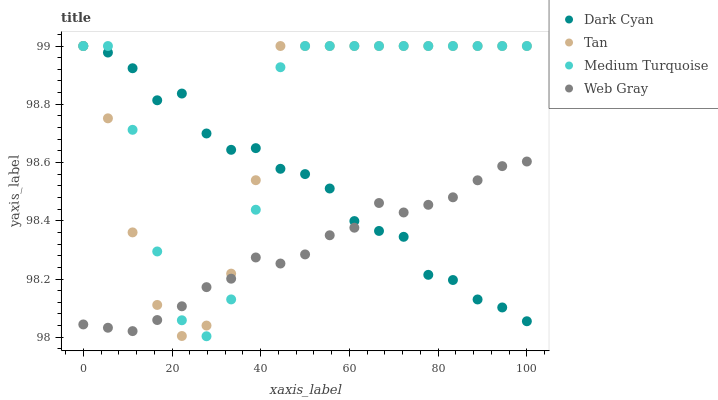Does Web Gray have the minimum area under the curve?
Answer yes or no. Yes. Does Medium Turquoise have the maximum area under the curve?
Answer yes or no. Yes. Does Tan have the minimum area under the curve?
Answer yes or no. No. Does Tan have the maximum area under the curve?
Answer yes or no. No. Is Web Gray the smoothest?
Answer yes or no. Yes. Is Medium Turquoise the roughest?
Answer yes or no. Yes. Is Tan the smoothest?
Answer yes or no. No. Is Tan the roughest?
Answer yes or no. No. Does Medium Turquoise have the lowest value?
Answer yes or no. Yes. Does Tan have the lowest value?
Answer yes or no. No. Does Medium Turquoise have the highest value?
Answer yes or no. Yes. Does Web Gray have the highest value?
Answer yes or no. No. Does Web Gray intersect Medium Turquoise?
Answer yes or no. Yes. Is Web Gray less than Medium Turquoise?
Answer yes or no. No. Is Web Gray greater than Medium Turquoise?
Answer yes or no. No. 